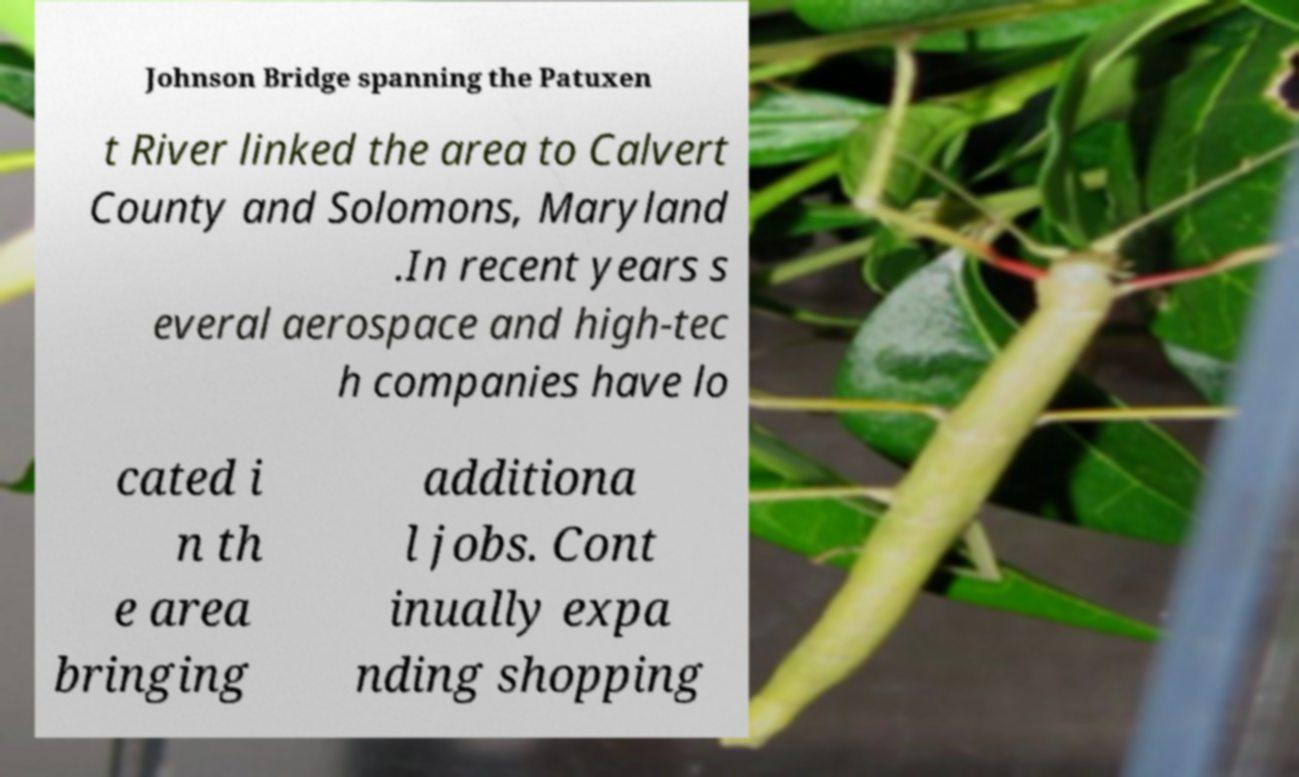Please read and relay the text visible in this image. What does it say? Johnson Bridge spanning the Patuxen t River linked the area to Calvert County and Solomons, Maryland .In recent years s everal aerospace and high-tec h companies have lo cated i n th e area bringing additiona l jobs. Cont inually expa nding shopping 